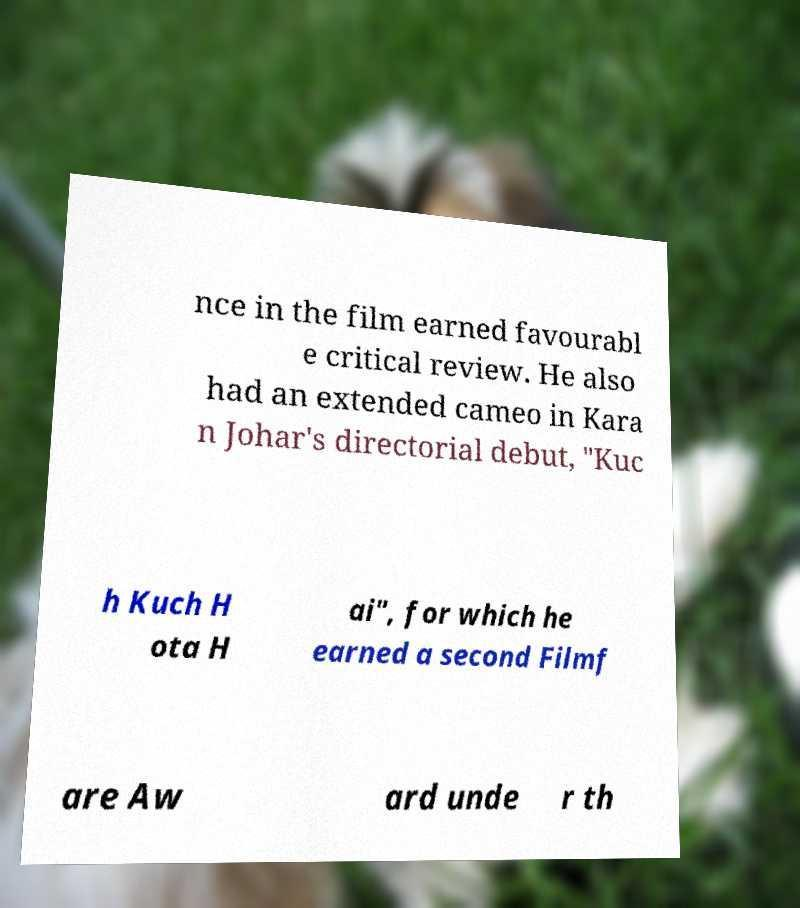What messages or text are displayed in this image? I need them in a readable, typed format. nce in the film earned favourabl e critical review. He also had an extended cameo in Kara n Johar's directorial debut, "Kuc h Kuch H ota H ai", for which he earned a second Filmf are Aw ard unde r th 